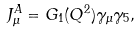<formula> <loc_0><loc_0><loc_500><loc_500>J ^ { A } _ { \mu } = G _ { 1 } ( Q ^ { 2 } ) \gamma _ { \mu } \gamma _ { 5 } ,</formula> 